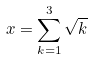<formula> <loc_0><loc_0><loc_500><loc_500>x = \sum _ { k = 1 } ^ { 3 } \sqrt { k }</formula> 